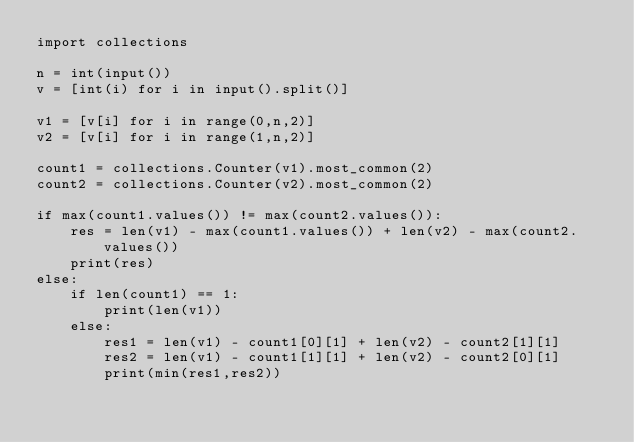<code> <loc_0><loc_0><loc_500><loc_500><_Python_>import collections
 
n = int(input())
v = [int(i) for i in input().split()]
 
v1 = [v[i] for i in range(0,n,2)]
v2 = [v[i] for i in range(1,n,2)]
 
count1 = collections.Counter(v1).most_common(2)
count2 = collections.Counter(v2).most_common(2)

if max(count1.values()) != max(count2.values()):
    res = len(v1) - max(count1.values()) + len(v2) - max(count2.values())
    print(res)
else:
    if len(count1) == 1:
        print(len(v1))
    else:
        res1 = len(v1) - count1[0][1] + len(v2) - count2[1][1]
        res2 = len(v1) - count1[1][1] + len(v2) - count2[0][1]
        print(min(res1,res2))
</code> 